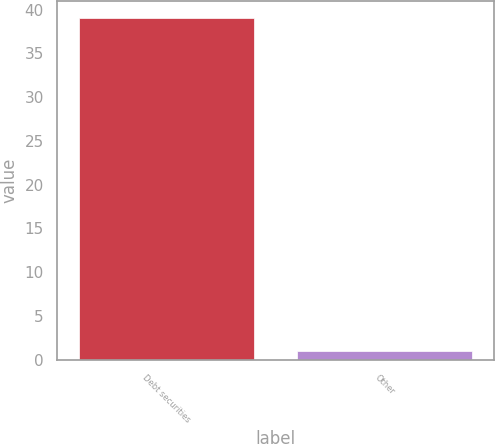Convert chart to OTSL. <chart><loc_0><loc_0><loc_500><loc_500><bar_chart><fcel>Debt securities<fcel>Other<nl><fcel>39<fcel>1<nl></chart> 